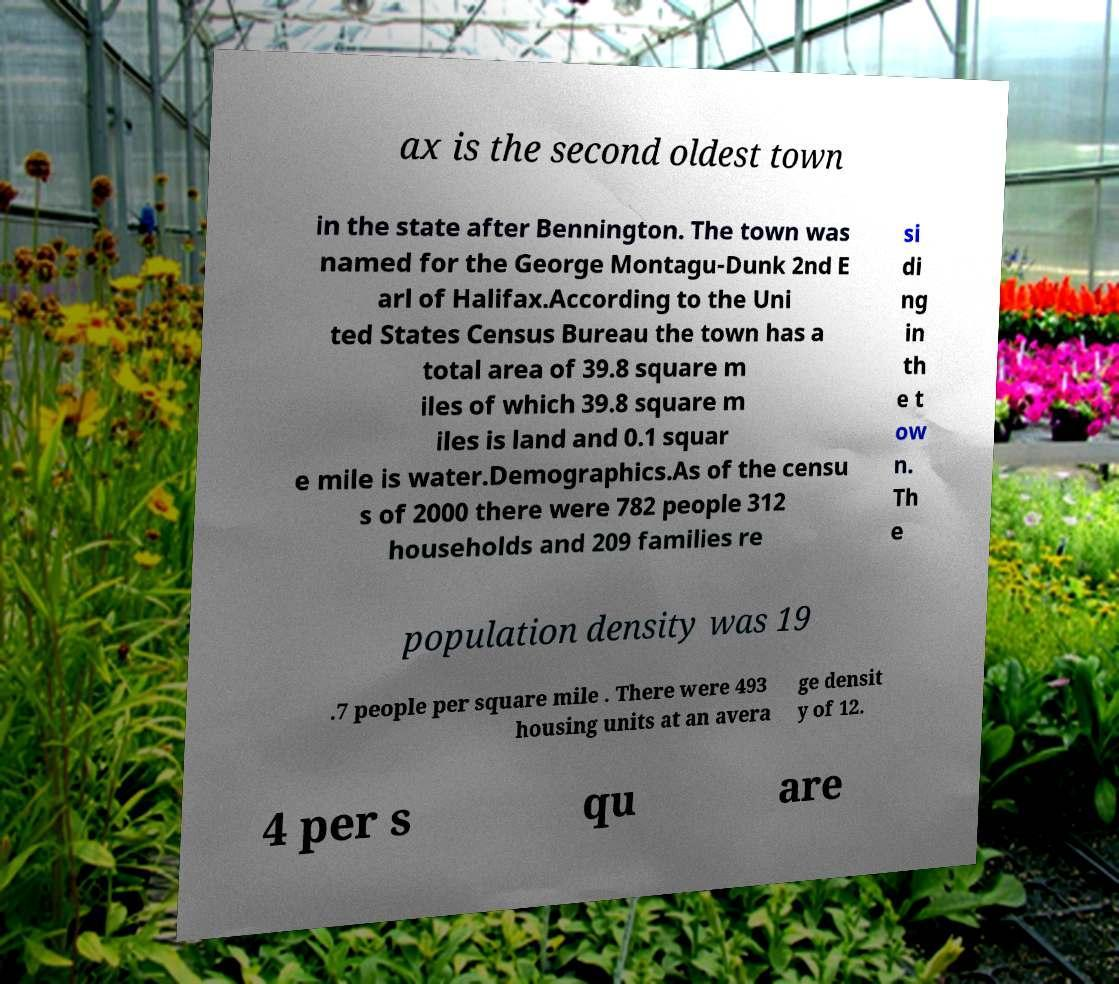For documentation purposes, I need the text within this image transcribed. Could you provide that? ax is the second oldest town in the state after Bennington. The town was named for the George Montagu-Dunk 2nd E arl of Halifax.According to the Uni ted States Census Bureau the town has a total area of 39.8 square m iles of which 39.8 square m iles is land and 0.1 squar e mile is water.Demographics.As of the censu s of 2000 there were 782 people 312 households and 209 families re si di ng in th e t ow n. Th e population density was 19 .7 people per square mile . There were 493 housing units at an avera ge densit y of 12. 4 per s qu are 